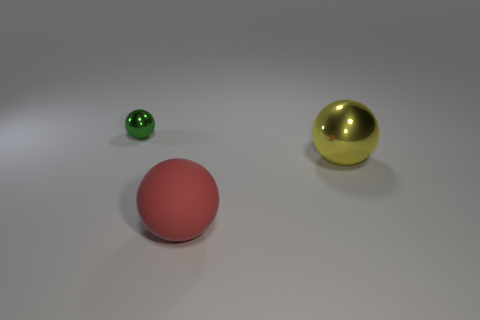Add 3 tiny shiny spheres. How many objects exist? 6 Add 2 yellow spheres. How many yellow spheres are left? 3 Add 3 red rubber objects. How many red rubber objects exist? 4 Subtract 0 cyan cylinders. How many objects are left? 3 Subtract all large gray metallic things. Subtract all yellow balls. How many objects are left? 2 